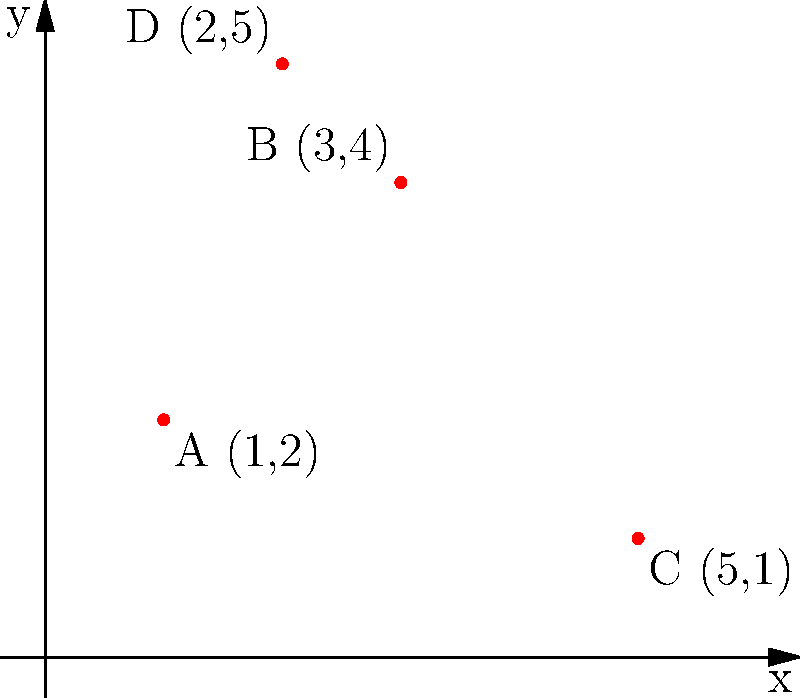As a dentist planning to expand your practice, you're analyzing the distribution of dental clinics in your city. The map shows the locations of four dental clinics (A, B, C, and D) plotted on a coordinate system. Which clinic is located farthest from the origin (0,0), and what is its distance from the origin? To solve this problem, we need to follow these steps:

1. Identify the coordinates of each clinic:
   A: (1,2)
   B: (3,4)
   C: (5,1)
   D: (2,5)

2. Calculate the distance of each clinic from the origin (0,0) using the distance formula:
   Distance = $\sqrt{x^2 + y^2}$

3. For clinic A: $\sqrt{1^2 + 2^2} = \sqrt{1 + 4} = \sqrt{5} \approx 2.24$
   For clinic B: $\sqrt{3^2 + 4^2} = \sqrt{9 + 16} = \sqrt{25} = 5$
   For clinic C: $\sqrt{5^2 + 1^2} = \sqrt{25 + 1} = \sqrt{26} \approx 5.10$
   For clinic D: $\sqrt{2^2 + 5^2} = \sqrt{4 + 25} = \sqrt{29} \approx 5.39$

4. Compare the distances:
   A: 2.24
   B: 5.00
   C: 5.10
   D: 5.39

5. Identify the clinic with the largest distance from the origin.

Clinic D has the largest distance from the origin at approximately 5.39 units.
Answer: Clinic D, 5.39 units 